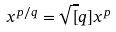Convert formula to latex. <formula><loc_0><loc_0><loc_500><loc_500>x ^ { p / q } = \sqrt { [ } q ] { x ^ { p } }</formula> 